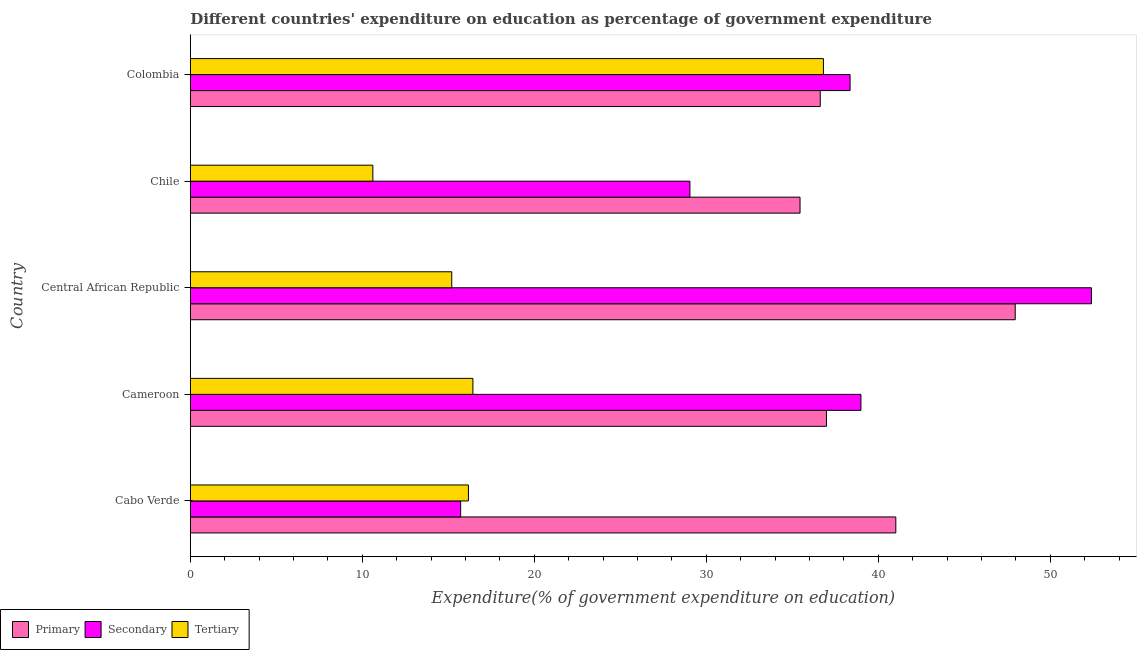How many groups of bars are there?
Ensure brevity in your answer.  5. Are the number of bars per tick equal to the number of legend labels?
Offer a terse response. Yes. Are the number of bars on each tick of the Y-axis equal?
Give a very brief answer. Yes. How many bars are there on the 2nd tick from the top?
Your response must be concise. 3. How many bars are there on the 2nd tick from the bottom?
Keep it short and to the point. 3. What is the label of the 4th group of bars from the top?
Your response must be concise. Cameroon. In how many cases, is the number of bars for a given country not equal to the number of legend labels?
Give a very brief answer. 0. What is the expenditure on tertiary education in Cabo Verde?
Ensure brevity in your answer.  16.17. Across all countries, what is the maximum expenditure on secondary education?
Make the answer very short. 52.4. Across all countries, what is the minimum expenditure on tertiary education?
Offer a terse response. 10.61. In which country was the expenditure on secondary education maximum?
Your response must be concise. Central African Republic. What is the total expenditure on primary education in the graph?
Make the answer very short. 198.06. What is the difference between the expenditure on secondary education in Cabo Verde and that in Chile?
Your answer should be compact. -13.33. What is the difference between the expenditure on tertiary education in Cameroon and the expenditure on secondary education in Chile?
Make the answer very short. -12.62. What is the average expenditure on secondary education per country?
Keep it short and to the point. 34.9. What is the difference between the expenditure on tertiary education and expenditure on secondary education in Chile?
Keep it short and to the point. -18.43. In how many countries, is the expenditure on tertiary education greater than 14 %?
Offer a terse response. 4. What is the ratio of the expenditure on secondary education in Chile to that in Colombia?
Your answer should be very brief. 0.76. Is the expenditure on tertiary education in Cabo Verde less than that in Chile?
Provide a short and direct response. No. Is the difference between the expenditure on primary education in Chile and Colombia greater than the difference between the expenditure on secondary education in Chile and Colombia?
Give a very brief answer. Yes. What is the difference between the highest and the second highest expenditure on primary education?
Keep it short and to the point. 6.94. What is the difference between the highest and the lowest expenditure on secondary education?
Your answer should be very brief. 36.68. In how many countries, is the expenditure on secondary education greater than the average expenditure on secondary education taken over all countries?
Provide a succinct answer. 3. Is the sum of the expenditure on tertiary education in Cabo Verde and Central African Republic greater than the maximum expenditure on secondary education across all countries?
Give a very brief answer. No. What does the 1st bar from the top in Cabo Verde represents?
Make the answer very short. Tertiary. What does the 2nd bar from the bottom in Cameroon represents?
Ensure brevity in your answer.  Secondary. Is it the case that in every country, the sum of the expenditure on primary education and expenditure on secondary education is greater than the expenditure on tertiary education?
Keep it short and to the point. Yes. How many bars are there?
Make the answer very short. 15. Are all the bars in the graph horizontal?
Offer a very short reply. Yes. How many countries are there in the graph?
Give a very brief answer. 5. Are the values on the major ticks of X-axis written in scientific E-notation?
Give a very brief answer. No. Does the graph contain any zero values?
Ensure brevity in your answer.  No. What is the title of the graph?
Your response must be concise. Different countries' expenditure on education as percentage of government expenditure. Does "Ages 50+" appear as one of the legend labels in the graph?
Provide a succinct answer. No. What is the label or title of the X-axis?
Offer a terse response. Expenditure(% of government expenditure on education). What is the label or title of the Y-axis?
Your answer should be compact. Country. What is the Expenditure(% of government expenditure on education) in Primary in Cabo Verde?
Provide a short and direct response. 41.02. What is the Expenditure(% of government expenditure on education) of Secondary in Cabo Verde?
Provide a short and direct response. 15.72. What is the Expenditure(% of government expenditure on education) in Tertiary in Cabo Verde?
Make the answer very short. 16.17. What is the Expenditure(% of government expenditure on education) of Primary in Cameroon?
Offer a terse response. 36.99. What is the Expenditure(% of government expenditure on education) of Secondary in Cameroon?
Offer a very short reply. 38.99. What is the Expenditure(% of government expenditure on education) in Tertiary in Cameroon?
Provide a short and direct response. 16.43. What is the Expenditure(% of government expenditure on education) in Primary in Central African Republic?
Offer a terse response. 47.96. What is the Expenditure(% of government expenditure on education) of Secondary in Central African Republic?
Give a very brief answer. 52.4. What is the Expenditure(% of government expenditure on education) in Tertiary in Central African Republic?
Give a very brief answer. 15.2. What is the Expenditure(% of government expenditure on education) in Primary in Chile?
Give a very brief answer. 35.45. What is the Expenditure(% of government expenditure on education) of Secondary in Chile?
Keep it short and to the point. 29.05. What is the Expenditure(% of government expenditure on education) of Tertiary in Chile?
Offer a very short reply. 10.61. What is the Expenditure(% of government expenditure on education) of Primary in Colombia?
Keep it short and to the point. 36.63. What is the Expenditure(% of government expenditure on education) in Secondary in Colombia?
Your answer should be very brief. 38.36. What is the Expenditure(% of government expenditure on education) in Tertiary in Colombia?
Give a very brief answer. 36.81. Across all countries, what is the maximum Expenditure(% of government expenditure on education) of Primary?
Your response must be concise. 47.96. Across all countries, what is the maximum Expenditure(% of government expenditure on education) of Secondary?
Provide a short and direct response. 52.4. Across all countries, what is the maximum Expenditure(% of government expenditure on education) in Tertiary?
Ensure brevity in your answer.  36.81. Across all countries, what is the minimum Expenditure(% of government expenditure on education) of Primary?
Your response must be concise. 35.45. Across all countries, what is the minimum Expenditure(% of government expenditure on education) of Secondary?
Provide a succinct answer. 15.72. Across all countries, what is the minimum Expenditure(% of government expenditure on education) in Tertiary?
Your answer should be compact. 10.61. What is the total Expenditure(% of government expenditure on education) in Primary in the graph?
Give a very brief answer. 198.06. What is the total Expenditure(% of government expenditure on education) of Secondary in the graph?
Make the answer very short. 174.52. What is the total Expenditure(% of government expenditure on education) of Tertiary in the graph?
Offer a terse response. 95.23. What is the difference between the Expenditure(% of government expenditure on education) of Primary in Cabo Verde and that in Cameroon?
Offer a very short reply. 4.03. What is the difference between the Expenditure(% of government expenditure on education) in Secondary in Cabo Verde and that in Cameroon?
Offer a terse response. -23.27. What is the difference between the Expenditure(% of government expenditure on education) of Tertiary in Cabo Verde and that in Cameroon?
Ensure brevity in your answer.  -0.26. What is the difference between the Expenditure(% of government expenditure on education) of Primary in Cabo Verde and that in Central African Republic?
Keep it short and to the point. -6.94. What is the difference between the Expenditure(% of government expenditure on education) of Secondary in Cabo Verde and that in Central African Republic?
Ensure brevity in your answer.  -36.68. What is the difference between the Expenditure(% of government expenditure on education) in Tertiary in Cabo Verde and that in Central African Republic?
Your answer should be very brief. 0.97. What is the difference between the Expenditure(% of government expenditure on education) of Primary in Cabo Verde and that in Chile?
Your response must be concise. 5.57. What is the difference between the Expenditure(% of government expenditure on education) of Secondary in Cabo Verde and that in Chile?
Provide a succinct answer. -13.33. What is the difference between the Expenditure(% of government expenditure on education) of Tertiary in Cabo Verde and that in Chile?
Keep it short and to the point. 5.56. What is the difference between the Expenditure(% of government expenditure on education) of Primary in Cabo Verde and that in Colombia?
Provide a succinct answer. 4.39. What is the difference between the Expenditure(% of government expenditure on education) in Secondary in Cabo Verde and that in Colombia?
Make the answer very short. -22.64. What is the difference between the Expenditure(% of government expenditure on education) in Tertiary in Cabo Verde and that in Colombia?
Your answer should be compact. -20.64. What is the difference between the Expenditure(% of government expenditure on education) of Primary in Cameroon and that in Central African Republic?
Your response must be concise. -10.97. What is the difference between the Expenditure(% of government expenditure on education) in Secondary in Cameroon and that in Central African Republic?
Ensure brevity in your answer.  -13.4. What is the difference between the Expenditure(% of government expenditure on education) in Tertiary in Cameroon and that in Central African Republic?
Your answer should be very brief. 1.23. What is the difference between the Expenditure(% of government expenditure on education) in Primary in Cameroon and that in Chile?
Offer a terse response. 1.54. What is the difference between the Expenditure(% of government expenditure on education) in Secondary in Cameroon and that in Chile?
Your response must be concise. 9.94. What is the difference between the Expenditure(% of government expenditure on education) of Tertiary in Cameroon and that in Chile?
Provide a succinct answer. 5.82. What is the difference between the Expenditure(% of government expenditure on education) in Primary in Cameroon and that in Colombia?
Give a very brief answer. 0.36. What is the difference between the Expenditure(% of government expenditure on education) of Secondary in Cameroon and that in Colombia?
Provide a short and direct response. 0.63. What is the difference between the Expenditure(% of government expenditure on education) of Tertiary in Cameroon and that in Colombia?
Provide a succinct answer. -20.38. What is the difference between the Expenditure(% of government expenditure on education) in Primary in Central African Republic and that in Chile?
Your answer should be compact. 12.51. What is the difference between the Expenditure(% of government expenditure on education) of Secondary in Central African Republic and that in Chile?
Offer a very short reply. 23.35. What is the difference between the Expenditure(% of government expenditure on education) of Tertiary in Central African Republic and that in Chile?
Give a very brief answer. 4.59. What is the difference between the Expenditure(% of government expenditure on education) of Primary in Central African Republic and that in Colombia?
Offer a terse response. 11.34. What is the difference between the Expenditure(% of government expenditure on education) of Secondary in Central African Republic and that in Colombia?
Provide a short and direct response. 14.03. What is the difference between the Expenditure(% of government expenditure on education) in Tertiary in Central African Republic and that in Colombia?
Your answer should be compact. -21.61. What is the difference between the Expenditure(% of government expenditure on education) in Primary in Chile and that in Colombia?
Offer a terse response. -1.18. What is the difference between the Expenditure(% of government expenditure on education) of Secondary in Chile and that in Colombia?
Provide a succinct answer. -9.31. What is the difference between the Expenditure(% of government expenditure on education) in Tertiary in Chile and that in Colombia?
Offer a very short reply. -26.2. What is the difference between the Expenditure(% of government expenditure on education) in Primary in Cabo Verde and the Expenditure(% of government expenditure on education) in Secondary in Cameroon?
Provide a short and direct response. 2.03. What is the difference between the Expenditure(% of government expenditure on education) in Primary in Cabo Verde and the Expenditure(% of government expenditure on education) in Tertiary in Cameroon?
Make the answer very short. 24.59. What is the difference between the Expenditure(% of government expenditure on education) in Secondary in Cabo Verde and the Expenditure(% of government expenditure on education) in Tertiary in Cameroon?
Provide a short and direct response. -0.71. What is the difference between the Expenditure(% of government expenditure on education) in Primary in Cabo Verde and the Expenditure(% of government expenditure on education) in Secondary in Central African Republic?
Provide a short and direct response. -11.37. What is the difference between the Expenditure(% of government expenditure on education) in Primary in Cabo Verde and the Expenditure(% of government expenditure on education) in Tertiary in Central African Republic?
Provide a succinct answer. 25.82. What is the difference between the Expenditure(% of government expenditure on education) in Secondary in Cabo Verde and the Expenditure(% of government expenditure on education) in Tertiary in Central African Republic?
Give a very brief answer. 0.52. What is the difference between the Expenditure(% of government expenditure on education) of Primary in Cabo Verde and the Expenditure(% of government expenditure on education) of Secondary in Chile?
Your answer should be very brief. 11.97. What is the difference between the Expenditure(% of government expenditure on education) in Primary in Cabo Verde and the Expenditure(% of government expenditure on education) in Tertiary in Chile?
Your answer should be compact. 30.41. What is the difference between the Expenditure(% of government expenditure on education) in Secondary in Cabo Verde and the Expenditure(% of government expenditure on education) in Tertiary in Chile?
Offer a very short reply. 5.1. What is the difference between the Expenditure(% of government expenditure on education) of Primary in Cabo Verde and the Expenditure(% of government expenditure on education) of Secondary in Colombia?
Ensure brevity in your answer.  2.66. What is the difference between the Expenditure(% of government expenditure on education) of Primary in Cabo Verde and the Expenditure(% of government expenditure on education) of Tertiary in Colombia?
Ensure brevity in your answer.  4.21. What is the difference between the Expenditure(% of government expenditure on education) in Secondary in Cabo Verde and the Expenditure(% of government expenditure on education) in Tertiary in Colombia?
Offer a terse response. -21.09. What is the difference between the Expenditure(% of government expenditure on education) of Primary in Cameroon and the Expenditure(% of government expenditure on education) of Secondary in Central African Republic?
Provide a succinct answer. -15.41. What is the difference between the Expenditure(% of government expenditure on education) of Primary in Cameroon and the Expenditure(% of government expenditure on education) of Tertiary in Central African Republic?
Offer a very short reply. 21.79. What is the difference between the Expenditure(% of government expenditure on education) of Secondary in Cameroon and the Expenditure(% of government expenditure on education) of Tertiary in Central African Republic?
Provide a short and direct response. 23.79. What is the difference between the Expenditure(% of government expenditure on education) in Primary in Cameroon and the Expenditure(% of government expenditure on education) in Secondary in Chile?
Provide a succinct answer. 7.94. What is the difference between the Expenditure(% of government expenditure on education) in Primary in Cameroon and the Expenditure(% of government expenditure on education) in Tertiary in Chile?
Make the answer very short. 26.37. What is the difference between the Expenditure(% of government expenditure on education) of Secondary in Cameroon and the Expenditure(% of government expenditure on education) of Tertiary in Chile?
Offer a very short reply. 28.38. What is the difference between the Expenditure(% of government expenditure on education) of Primary in Cameroon and the Expenditure(% of government expenditure on education) of Secondary in Colombia?
Offer a terse response. -1.37. What is the difference between the Expenditure(% of government expenditure on education) in Primary in Cameroon and the Expenditure(% of government expenditure on education) in Tertiary in Colombia?
Your response must be concise. 0.18. What is the difference between the Expenditure(% of government expenditure on education) in Secondary in Cameroon and the Expenditure(% of government expenditure on education) in Tertiary in Colombia?
Give a very brief answer. 2.18. What is the difference between the Expenditure(% of government expenditure on education) in Primary in Central African Republic and the Expenditure(% of government expenditure on education) in Secondary in Chile?
Offer a very short reply. 18.91. What is the difference between the Expenditure(% of government expenditure on education) in Primary in Central African Republic and the Expenditure(% of government expenditure on education) in Tertiary in Chile?
Your answer should be compact. 37.35. What is the difference between the Expenditure(% of government expenditure on education) in Secondary in Central African Republic and the Expenditure(% of government expenditure on education) in Tertiary in Chile?
Provide a short and direct response. 41.78. What is the difference between the Expenditure(% of government expenditure on education) in Primary in Central African Republic and the Expenditure(% of government expenditure on education) in Secondary in Colombia?
Keep it short and to the point. 9.6. What is the difference between the Expenditure(% of government expenditure on education) of Primary in Central African Republic and the Expenditure(% of government expenditure on education) of Tertiary in Colombia?
Provide a short and direct response. 11.15. What is the difference between the Expenditure(% of government expenditure on education) in Secondary in Central African Republic and the Expenditure(% of government expenditure on education) in Tertiary in Colombia?
Keep it short and to the point. 15.58. What is the difference between the Expenditure(% of government expenditure on education) in Primary in Chile and the Expenditure(% of government expenditure on education) in Secondary in Colombia?
Offer a very short reply. -2.91. What is the difference between the Expenditure(% of government expenditure on education) in Primary in Chile and the Expenditure(% of government expenditure on education) in Tertiary in Colombia?
Provide a succinct answer. -1.36. What is the difference between the Expenditure(% of government expenditure on education) in Secondary in Chile and the Expenditure(% of government expenditure on education) in Tertiary in Colombia?
Your response must be concise. -7.76. What is the average Expenditure(% of government expenditure on education) in Primary per country?
Make the answer very short. 39.61. What is the average Expenditure(% of government expenditure on education) of Secondary per country?
Ensure brevity in your answer.  34.9. What is the average Expenditure(% of government expenditure on education) in Tertiary per country?
Give a very brief answer. 19.05. What is the difference between the Expenditure(% of government expenditure on education) in Primary and Expenditure(% of government expenditure on education) in Secondary in Cabo Verde?
Your answer should be very brief. 25.3. What is the difference between the Expenditure(% of government expenditure on education) of Primary and Expenditure(% of government expenditure on education) of Tertiary in Cabo Verde?
Your answer should be compact. 24.85. What is the difference between the Expenditure(% of government expenditure on education) of Secondary and Expenditure(% of government expenditure on education) of Tertiary in Cabo Verde?
Provide a succinct answer. -0.45. What is the difference between the Expenditure(% of government expenditure on education) of Primary and Expenditure(% of government expenditure on education) of Secondary in Cameroon?
Your answer should be compact. -2. What is the difference between the Expenditure(% of government expenditure on education) of Primary and Expenditure(% of government expenditure on education) of Tertiary in Cameroon?
Make the answer very short. 20.56. What is the difference between the Expenditure(% of government expenditure on education) of Secondary and Expenditure(% of government expenditure on education) of Tertiary in Cameroon?
Provide a short and direct response. 22.56. What is the difference between the Expenditure(% of government expenditure on education) of Primary and Expenditure(% of government expenditure on education) of Secondary in Central African Republic?
Make the answer very short. -4.43. What is the difference between the Expenditure(% of government expenditure on education) in Primary and Expenditure(% of government expenditure on education) in Tertiary in Central African Republic?
Your response must be concise. 32.76. What is the difference between the Expenditure(% of government expenditure on education) in Secondary and Expenditure(% of government expenditure on education) in Tertiary in Central African Republic?
Keep it short and to the point. 37.19. What is the difference between the Expenditure(% of government expenditure on education) in Primary and Expenditure(% of government expenditure on education) in Secondary in Chile?
Offer a very short reply. 6.4. What is the difference between the Expenditure(% of government expenditure on education) in Primary and Expenditure(% of government expenditure on education) in Tertiary in Chile?
Provide a short and direct response. 24.84. What is the difference between the Expenditure(% of government expenditure on education) in Secondary and Expenditure(% of government expenditure on education) in Tertiary in Chile?
Make the answer very short. 18.44. What is the difference between the Expenditure(% of government expenditure on education) in Primary and Expenditure(% of government expenditure on education) in Secondary in Colombia?
Provide a short and direct response. -1.73. What is the difference between the Expenditure(% of government expenditure on education) in Primary and Expenditure(% of government expenditure on education) in Tertiary in Colombia?
Make the answer very short. -0.18. What is the difference between the Expenditure(% of government expenditure on education) in Secondary and Expenditure(% of government expenditure on education) in Tertiary in Colombia?
Provide a succinct answer. 1.55. What is the ratio of the Expenditure(% of government expenditure on education) in Primary in Cabo Verde to that in Cameroon?
Make the answer very short. 1.11. What is the ratio of the Expenditure(% of government expenditure on education) in Secondary in Cabo Verde to that in Cameroon?
Ensure brevity in your answer.  0.4. What is the ratio of the Expenditure(% of government expenditure on education) in Tertiary in Cabo Verde to that in Cameroon?
Your answer should be compact. 0.98. What is the ratio of the Expenditure(% of government expenditure on education) in Primary in Cabo Verde to that in Central African Republic?
Offer a very short reply. 0.86. What is the ratio of the Expenditure(% of government expenditure on education) in Tertiary in Cabo Verde to that in Central African Republic?
Ensure brevity in your answer.  1.06. What is the ratio of the Expenditure(% of government expenditure on education) in Primary in Cabo Verde to that in Chile?
Your response must be concise. 1.16. What is the ratio of the Expenditure(% of government expenditure on education) in Secondary in Cabo Verde to that in Chile?
Make the answer very short. 0.54. What is the ratio of the Expenditure(% of government expenditure on education) in Tertiary in Cabo Verde to that in Chile?
Offer a terse response. 1.52. What is the ratio of the Expenditure(% of government expenditure on education) in Primary in Cabo Verde to that in Colombia?
Keep it short and to the point. 1.12. What is the ratio of the Expenditure(% of government expenditure on education) of Secondary in Cabo Verde to that in Colombia?
Provide a succinct answer. 0.41. What is the ratio of the Expenditure(% of government expenditure on education) in Tertiary in Cabo Verde to that in Colombia?
Offer a terse response. 0.44. What is the ratio of the Expenditure(% of government expenditure on education) in Primary in Cameroon to that in Central African Republic?
Your answer should be compact. 0.77. What is the ratio of the Expenditure(% of government expenditure on education) in Secondary in Cameroon to that in Central African Republic?
Ensure brevity in your answer.  0.74. What is the ratio of the Expenditure(% of government expenditure on education) in Tertiary in Cameroon to that in Central African Republic?
Provide a short and direct response. 1.08. What is the ratio of the Expenditure(% of government expenditure on education) of Primary in Cameroon to that in Chile?
Make the answer very short. 1.04. What is the ratio of the Expenditure(% of government expenditure on education) of Secondary in Cameroon to that in Chile?
Offer a very short reply. 1.34. What is the ratio of the Expenditure(% of government expenditure on education) of Tertiary in Cameroon to that in Chile?
Make the answer very short. 1.55. What is the ratio of the Expenditure(% of government expenditure on education) in Primary in Cameroon to that in Colombia?
Your answer should be very brief. 1.01. What is the ratio of the Expenditure(% of government expenditure on education) in Secondary in Cameroon to that in Colombia?
Your answer should be very brief. 1.02. What is the ratio of the Expenditure(% of government expenditure on education) of Tertiary in Cameroon to that in Colombia?
Keep it short and to the point. 0.45. What is the ratio of the Expenditure(% of government expenditure on education) in Primary in Central African Republic to that in Chile?
Offer a very short reply. 1.35. What is the ratio of the Expenditure(% of government expenditure on education) of Secondary in Central African Republic to that in Chile?
Your answer should be very brief. 1.8. What is the ratio of the Expenditure(% of government expenditure on education) in Tertiary in Central African Republic to that in Chile?
Ensure brevity in your answer.  1.43. What is the ratio of the Expenditure(% of government expenditure on education) in Primary in Central African Republic to that in Colombia?
Provide a short and direct response. 1.31. What is the ratio of the Expenditure(% of government expenditure on education) of Secondary in Central African Republic to that in Colombia?
Make the answer very short. 1.37. What is the ratio of the Expenditure(% of government expenditure on education) in Tertiary in Central African Republic to that in Colombia?
Provide a short and direct response. 0.41. What is the ratio of the Expenditure(% of government expenditure on education) of Primary in Chile to that in Colombia?
Your answer should be compact. 0.97. What is the ratio of the Expenditure(% of government expenditure on education) of Secondary in Chile to that in Colombia?
Provide a succinct answer. 0.76. What is the ratio of the Expenditure(% of government expenditure on education) in Tertiary in Chile to that in Colombia?
Give a very brief answer. 0.29. What is the difference between the highest and the second highest Expenditure(% of government expenditure on education) in Primary?
Offer a terse response. 6.94. What is the difference between the highest and the second highest Expenditure(% of government expenditure on education) of Secondary?
Offer a very short reply. 13.4. What is the difference between the highest and the second highest Expenditure(% of government expenditure on education) of Tertiary?
Your answer should be compact. 20.38. What is the difference between the highest and the lowest Expenditure(% of government expenditure on education) in Primary?
Offer a terse response. 12.51. What is the difference between the highest and the lowest Expenditure(% of government expenditure on education) in Secondary?
Your response must be concise. 36.68. What is the difference between the highest and the lowest Expenditure(% of government expenditure on education) of Tertiary?
Provide a succinct answer. 26.2. 